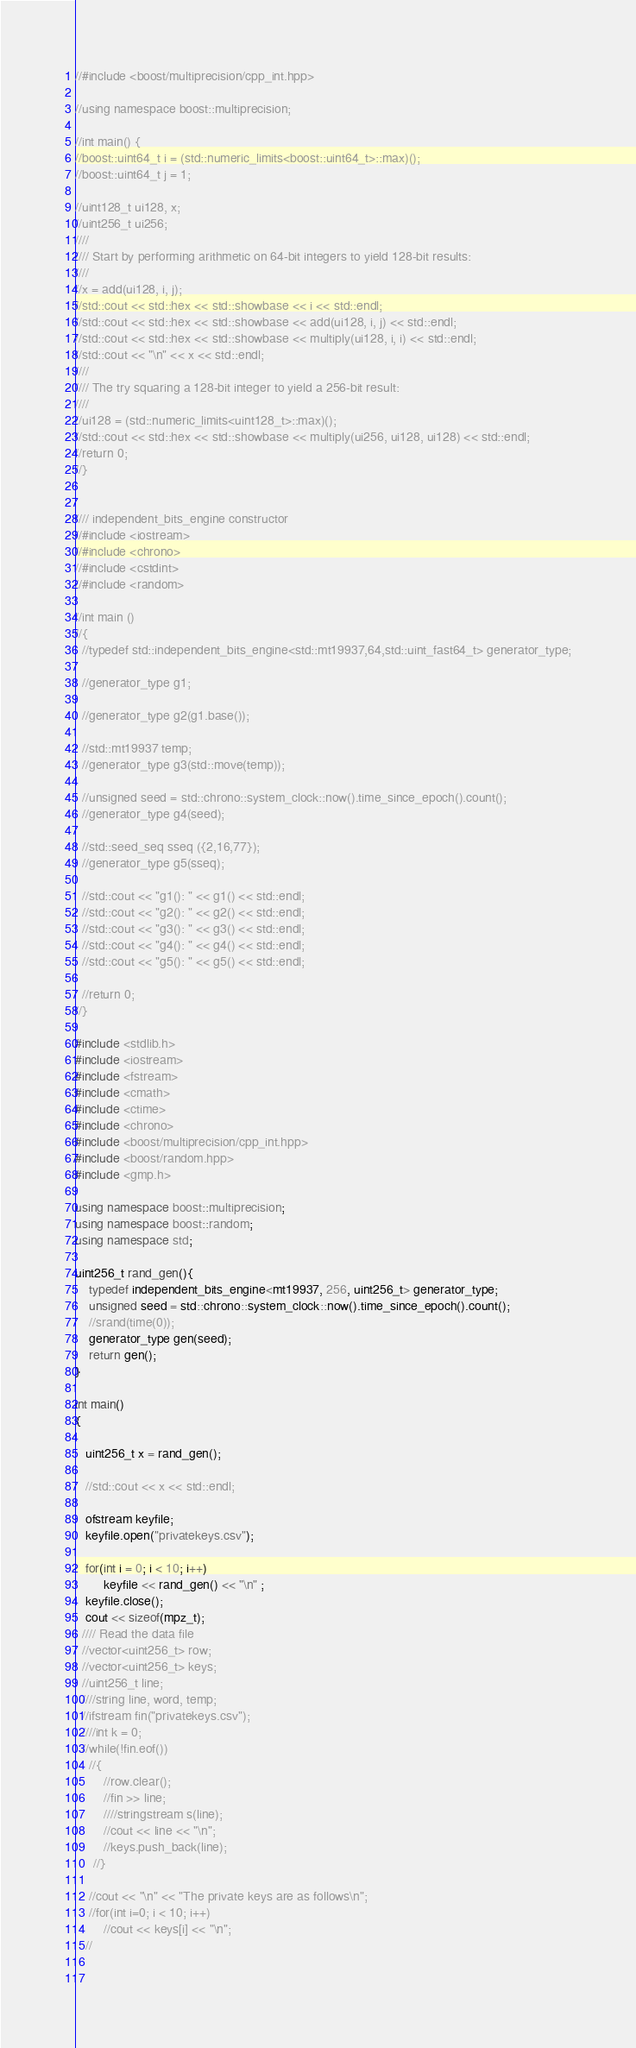<code> <loc_0><loc_0><loc_500><loc_500><_C++_>//#include <boost/multiprecision/cpp_int.hpp>

//using namespace boost::multiprecision;

//int main() {
//boost::uint64_t i = (std::numeric_limits<boost::uint64_t>::max)();
//boost::uint64_t j = 1;

//uint128_t ui128, x;
//uint256_t ui256;
////
//// Start by performing arithmetic on 64-bit integers to yield 128-bit results:
////
//x = add(ui128, i, j);
//std::cout << std::hex << std::showbase << i << std::endl;
//std::cout << std::hex << std::showbase << add(ui128, i, j) << std::endl;
//std::cout << std::hex << std::showbase << multiply(ui128, i, i) << std::endl;
//std::cout << "\n" << x << std::endl;
////
//// The try squaring a 128-bit integer to yield a 256-bit result:
////
//ui128 = (std::numeric_limits<uint128_t>::max)();
//std::cout << std::hex << std::showbase << multiply(ui256, ui128, ui128) << std::endl;
//return 0;
//}


//// independent_bits_engine constructor
//#include <iostream>
//#include <chrono>
//#include <cstdint>
//#include <random>

//int main ()
//{
  //typedef std::independent_bits_engine<std::mt19937,64,std::uint_fast64_t> generator_type;

  //generator_type g1;

  //generator_type g2(g1.base());

  //std::mt19937 temp;
  //generator_type g3(std::move(temp));

  //unsigned seed = std::chrono::system_clock::now().time_since_epoch().count();
  //generator_type g4(seed);

  //std::seed_seq sseq ({2,16,77});
  //generator_type g5(sseq);

  //std::cout << "g1(): " << g1() << std::endl;
  //std::cout << "g2(): " << g2() << std::endl;
  //std::cout << "g3(): " << g3() << std::endl;
  //std::cout << "g4(): " << g4() << std::endl;
  //std::cout << "g5(): " << g5() << std::endl;

  //return 0;
//}

#include <stdlib.h>
#include <iostream>
#include <fstream>
#include <cmath>
#include <ctime>
#include <chrono>
#include <boost/multiprecision/cpp_int.hpp>
#include <boost/random.hpp>
#include <gmp.h>

using namespace boost::multiprecision;
using namespace boost::random;
using namespace std;

uint256_t rand_gen(){
	typedef independent_bits_engine<mt19937, 256, uint256_t> generator_type;
    unsigned seed = std::chrono::system_clock::now().time_since_epoch().count();
    //srand(time(0));
    generator_type gen(seed);
    return gen();
}

int main()
{

   uint256_t x = rand_gen();
   
   //std::cout << x << std::endl;
   
   ofstream keyfile;
   keyfile.open("privatekeys.csv");
   
   for(int i = 0; i < 10; i++)
        keyfile << rand_gen() << "\n" ;
   keyfile.close();
   cout << sizeof(mpz_t);
  //// Read the data file
  //vector<uint256_t> row;
  //vector<uint256_t> keys;
  //uint256_t line;
  ////string line, word, temp;
  //ifstream fin("privatekeys.csv");
  ////int k = 0;
  //while(!fin.eof())
	//{
		//row.clear();
		//fin >> line;
		////stringstream s(line);
		//cout << line << "\n";
		//keys.push_back(line);
     //}
     
	//cout << "\n" << "The private keys are as follows\n";
	//for(int i=0; i < 10; i++)
		//cout << keys[i] << "\n";
   //
   
   </code> 